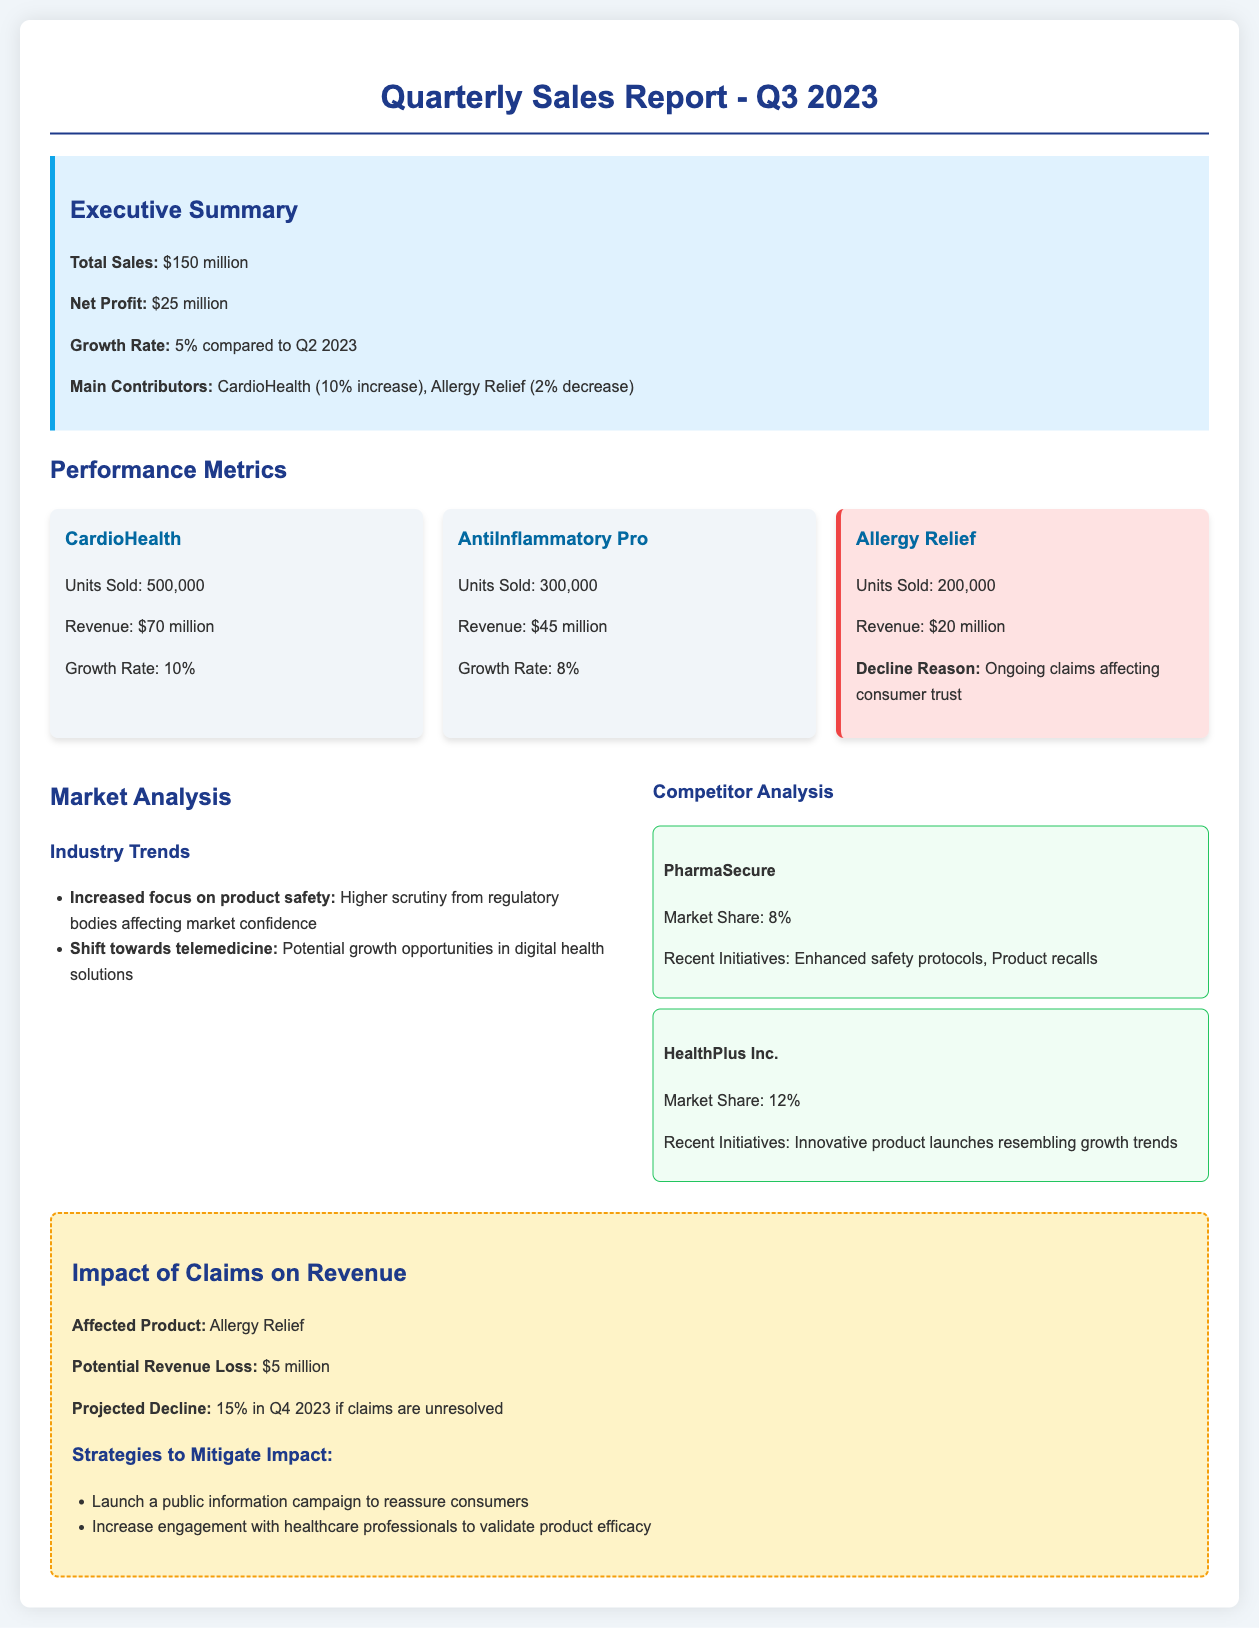What is the total sales? The total sales figure is prominently stated in the executive summary section of the document.
Answer: $150 million What is the growth rate compared to Q2 2023? The growth rate is mentioned in the executive summary, indicating how performance has changed over the previous quarter.
Answer: 5% Which product had a decline in units sold? The document lists product performance metrics, noting any declines in a dedicated section.
Answer: Allergy Relief What is the revenue for CardioHealth? The revenue for CardioHealth is specified within its performance metrics card.
Answer: $70 million What is the potential revenue loss due to claims? The impact of claims section details the specific potential revenue loss associated with ongoing claims.
Answer: $5 million Which competitor has the highest market share? The market analysis compares competitors based on their market share and recent initiatives.
Answer: HealthPlus Inc What is projected to be the decline percentage in Q4 2023 if claims are unresolved? The projected decline is mentioned under the impact of claims on revenue, specifically detailing future expectations.
Answer: 15% What are the main contributors to total sales growth? The executive summary outlines products that contributed positively or negatively to sales growth.
Answer: CardioHealth What is the main reason for the decline in Allergy Relief sales? The underperforming product section explains the reason for its sales decline related to consumer perception.
Answer: Ongoing claims affecting consumer trust 